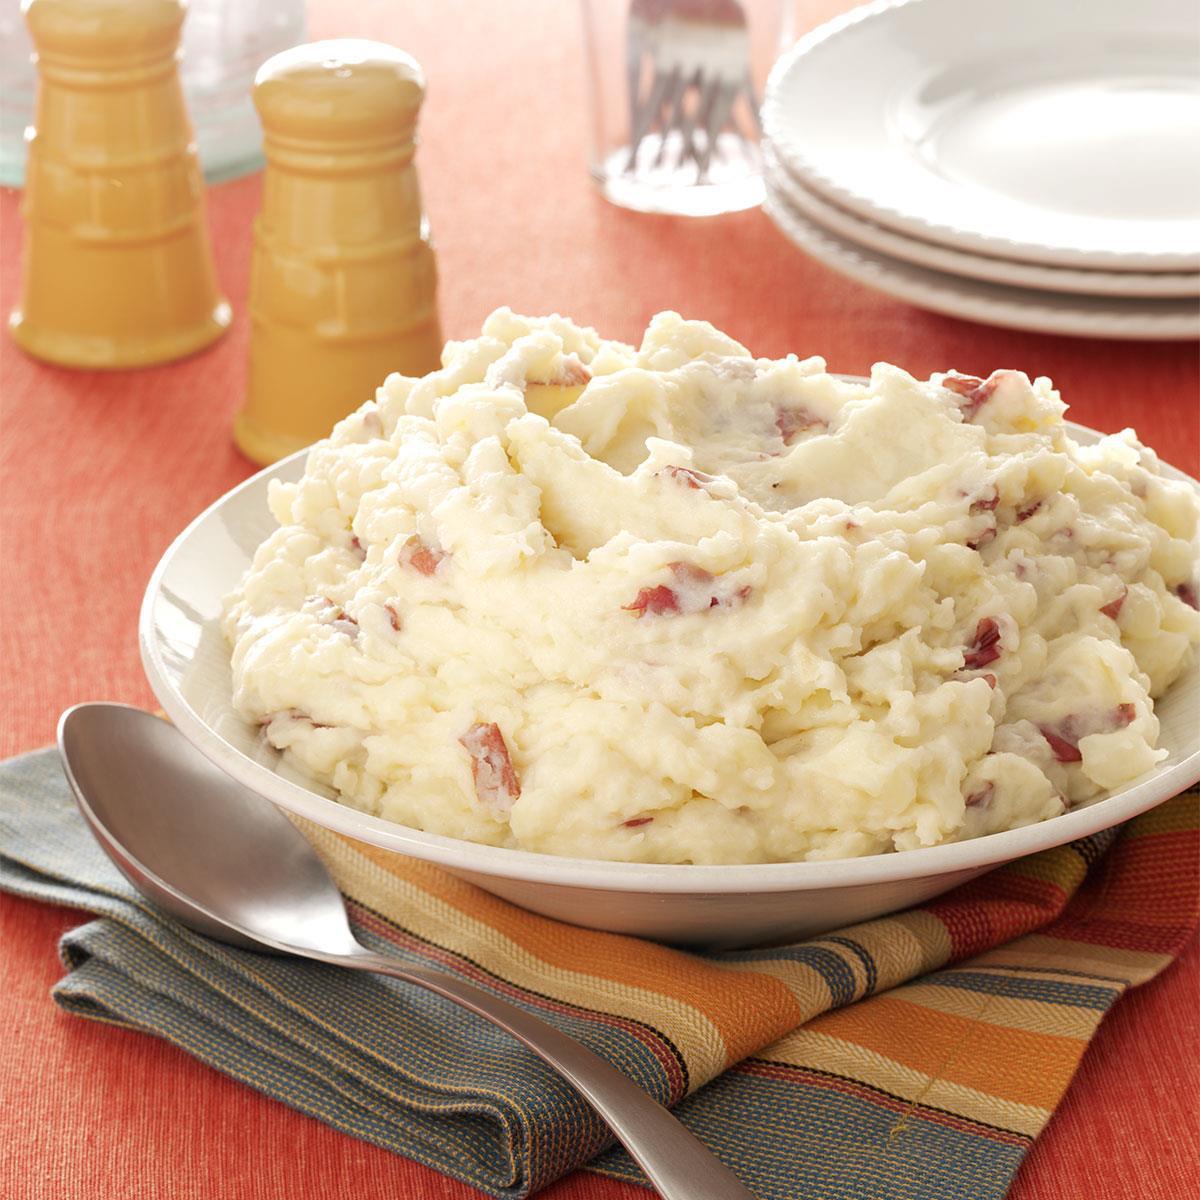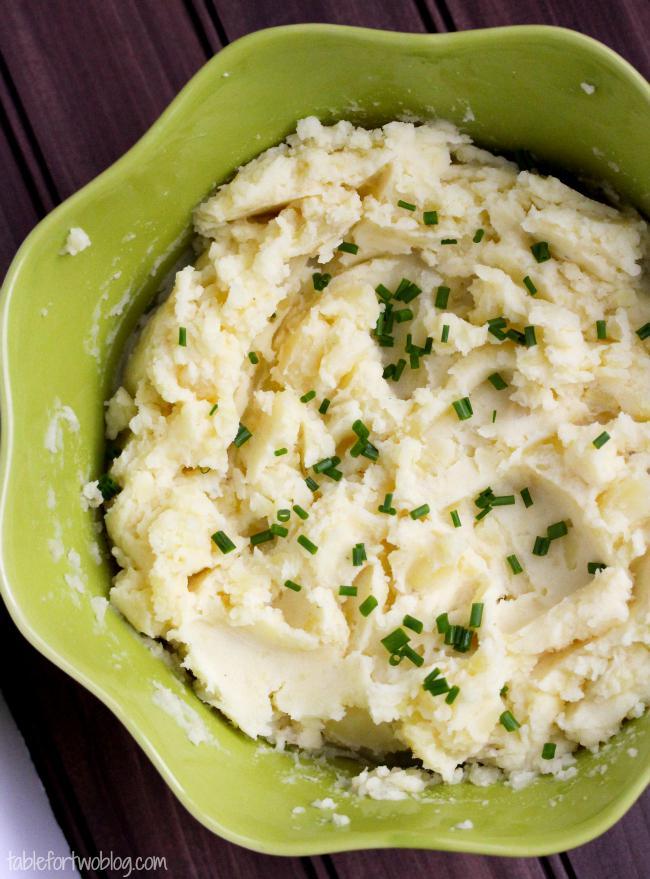The first image is the image on the left, the second image is the image on the right. Assess this claim about the two images: "The food in the image on the right  is in a green bowl.". Correct or not? Answer yes or no. Yes. The first image is the image on the left, the second image is the image on the right. Assess this claim about the two images: "An image shows mashed potatoes garnished with chives and served in an olive-green bowl.". Correct or not? Answer yes or no. Yes. 